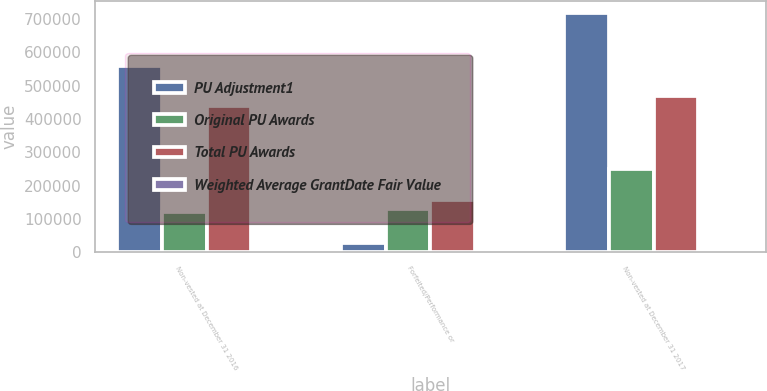Convert chart. <chart><loc_0><loc_0><loc_500><loc_500><stacked_bar_chart><ecel><fcel>Non-vested at December 31 2016<fcel>Forfeited/Performance or<fcel>Non-vested at December 31 2017<nl><fcel>PU Adjustment1<fcel>559340<fcel>28670<fcel>717878<nl><fcel>Original PU Awards<fcel>121038<fcel>129029<fcel>250067<nl><fcel>Total PU Awards<fcel>438302<fcel>157699<fcel>467811<nl><fcel>Weighted Average GrantDate Fair Value<fcel>33.67<fcel>30.25<fcel>39.28<nl></chart> 